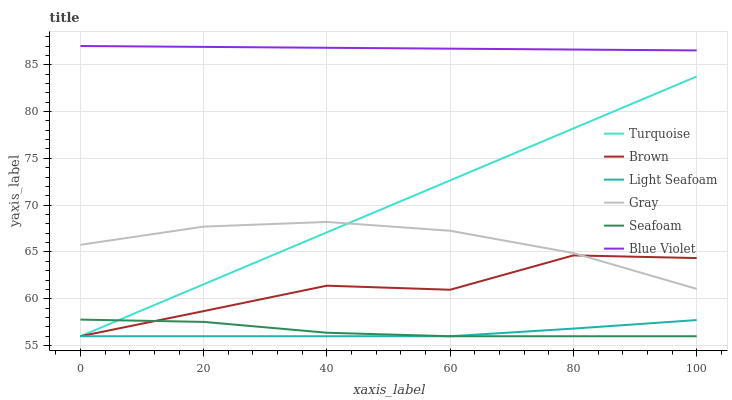Does Light Seafoam have the minimum area under the curve?
Answer yes or no. Yes. Does Blue Violet have the maximum area under the curve?
Answer yes or no. Yes. Does Turquoise have the minimum area under the curve?
Answer yes or no. No. Does Turquoise have the maximum area under the curve?
Answer yes or no. No. Is Turquoise the smoothest?
Answer yes or no. Yes. Is Brown the roughest?
Answer yes or no. Yes. Is Gray the smoothest?
Answer yes or no. No. Is Gray the roughest?
Answer yes or no. No. Does Brown have the lowest value?
Answer yes or no. Yes. Does Gray have the lowest value?
Answer yes or no. No. Does Blue Violet have the highest value?
Answer yes or no. Yes. Does Turquoise have the highest value?
Answer yes or no. No. Is Seafoam less than Gray?
Answer yes or no. Yes. Is Blue Violet greater than Turquoise?
Answer yes or no. Yes. Does Brown intersect Light Seafoam?
Answer yes or no. Yes. Is Brown less than Light Seafoam?
Answer yes or no. No. Is Brown greater than Light Seafoam?
Answer yes or no. No. Does Seafoam intersect Gray?
Answer yes or no. No. 